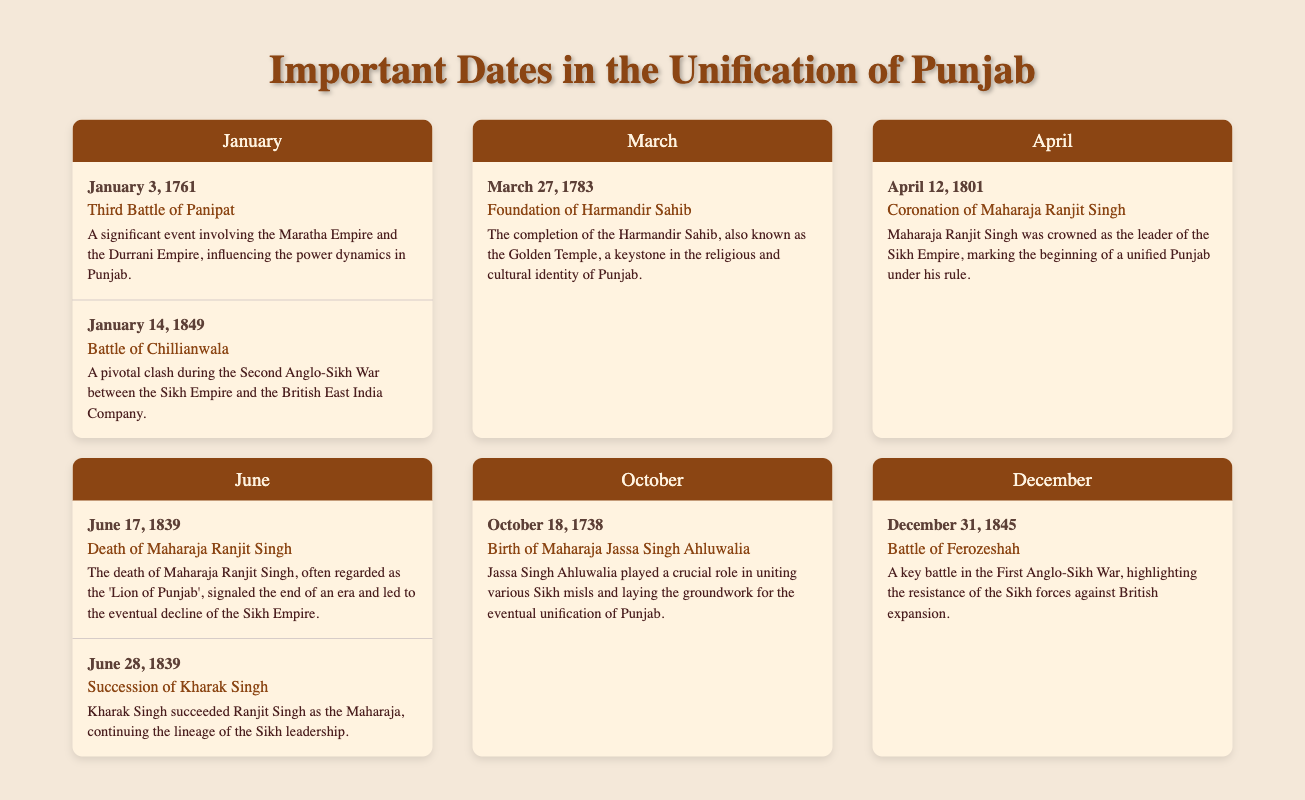Which battle is associated with the First Anglo-Sikh War? The document identifies the "Battle of Ferozeshah" as associated with the First Anglo-Sikh War.
Answer: Battle of Ferozeshah 